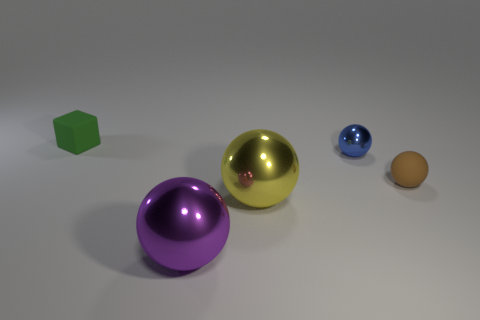What number of brown balls are the same size as the yellow metal sphere?
Provide a short and direct response. 0. Is the number of brown objects on the left side of the purple ball the same as the number of cyan matte things?
Ensure brevity in your answer.  Yes. How many small things are both to the left of the small brown matte object and in front of the rubber cube?
Offer a terse response. 1. There is a brown thing that is made of the same material as the tiny green block; what size is it?
Provide a short and direct response. Small. What number of other shiny things have the same shape as the small metal object?
Your response must be concise. 2. Are there more purple balls on the left side of the large purple ball than brown cylinders?
Keep it short and to the point. No. There is a metallic thing that is behind the large purple shiny thing and in front of the tiny brown matte ball; what is its shape?
Make the answer very short. Sphere. Is the size of the purple metal sphere the same as the blue metallic ball?
Offer a terse response. No. How many tiny brown spheres are to the left of the green cube?
Your response must be concise. 0. Are there the same number of large yellow spheres behind the tiny brown sphere and matte things on the left side of the large purple metal sphere?
Your answer should be compact. No. 